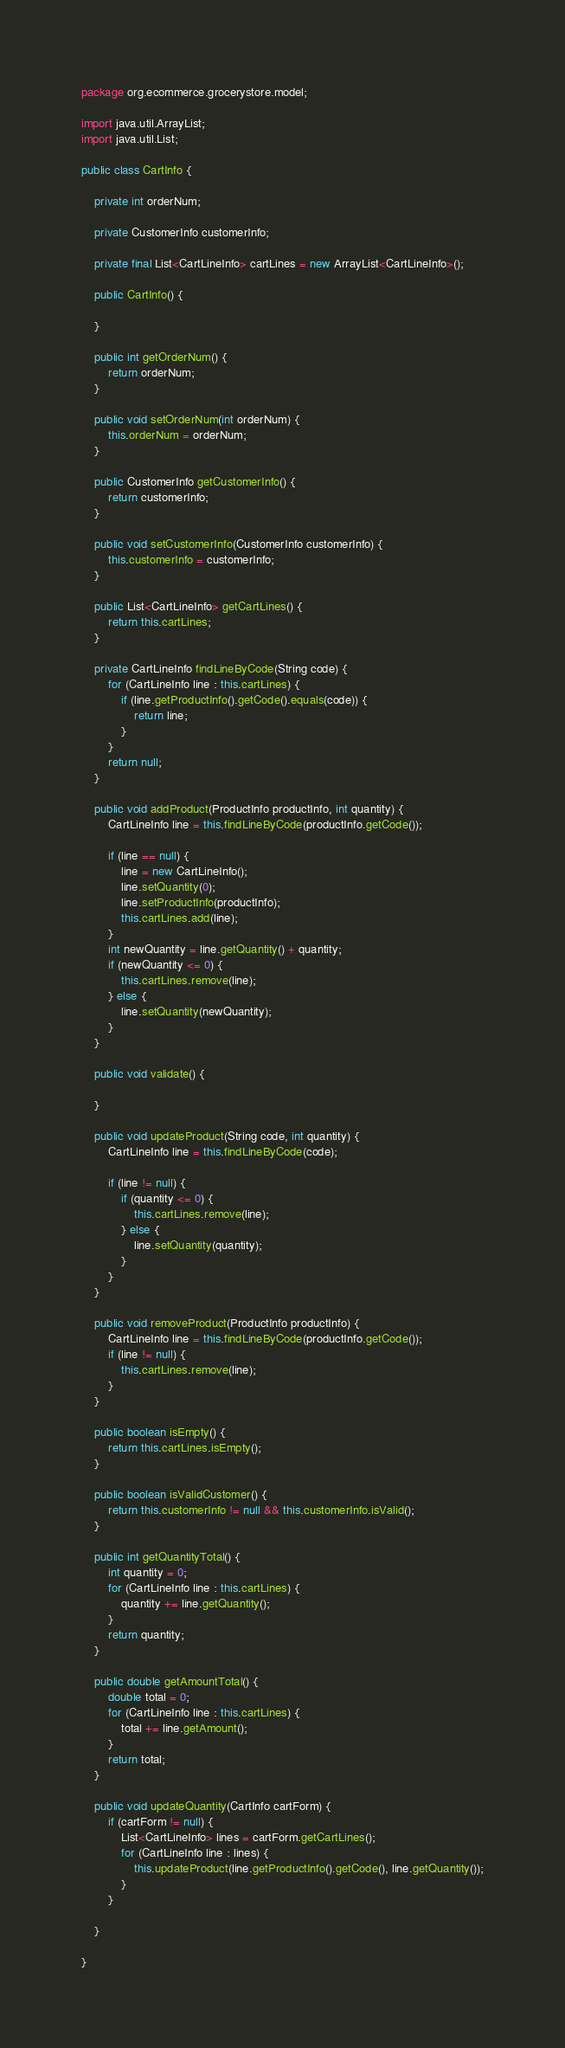<code> <loc_0><loc_0><loc_500><loc_500><_Java_>package org.ecommerce.grocerystore.model;

import java.util.ArrayList;
import java.util.List;

public class CartInfo {

    private int orderNum;

    private CustomerInfo customerInfo;

    private final List<CartLineInfo> cartLines = new ArrayList<CartLineInfo>();

    public CartInfo() {

    }

    public int getOrderNum() {
        return orderNum;
    }

    public void setOrderNum(int orderNum) {
        this.orderNum = orderNum;
    }

    public CustomerInfo getCustomerInfo() {
        return customerInfo;
    }

    public void setCustomerInfo(CustomerInfo customerInfo) {
        this.customerInfo = customerInfo;
    }

    public List<CartLineInfo> getCartLines() {
        return this.cartLines;
    }

    private CartLineInfo findLineByCode(String code) {
        for (CartLineInfo line : this.cartLines) {
            if (line.getProductInfo().getCode().equals(code)) {
                return line;
            }
        }
        return null;
    }

    public void addProduct(ProductInfo productInfo, int quantity) {
        CartLineInfo line = this.findLineByCode(productInfo.getCode());

        if (line == null) {
            line = new CartLineInfo();
            line.setQuantity(0);
            line.setProductInfo(productInfo);
            this.cartLines.add(line);
        }
        int newQuantity = line.getQuantity() + quantity;
        if (newQuantity <= 0) {
            this.cartLines.remove(line);
        } else {
            line.setQuantity(newQuantity);
        }
    }

    public void validate() {

    }

    public void updateProduct(String code, int quantity) {
        CartLineInfo line = this.findLineByCode(code);

        if (line != null) {
            if (quantity <= 0) {
                this.cartLines.remove(line);
            } else {
                line.setQuantity(quantity);
            }
        }
    }

    public void removeProduct(ProductInfo productInfo) {
        CartLineInfo line = this.findLineByCode(productInfo.getCode());
        if (line != null) {
            this.cartLines.remove(line);
        }
    }

    public boolean isEmpty() {
        return this.cartLines.isEmpty();
    }

    public boolean isValidCustomer() {
        return this.customerInfo != null && this.customerInfo.isValid();
    }

    public int getQuantityTotal() {
        int quantity = 0;
        for (CartLineInfo line : this.cartLines) {
            quantity += line.getQuantity();
        }
        return quantity;
    }

    public double getAmountTotal() {
        double total = 0;
        for (CartLineInfo line : this.cartLines) {
            total += line.getAmount();
        }
        return total;
    }

    public void updateQuantity(CartInfo cartForm) {
        if (cartForm != null) {
            List<CartLineInfo> lines = cartForm.getCartLines();
            for (CartLineInfo line : lines) {
                this.updateProduct(line.getProductInfo().getCode(), line.getQuantity());
            }
        }

    }

}
</code> 